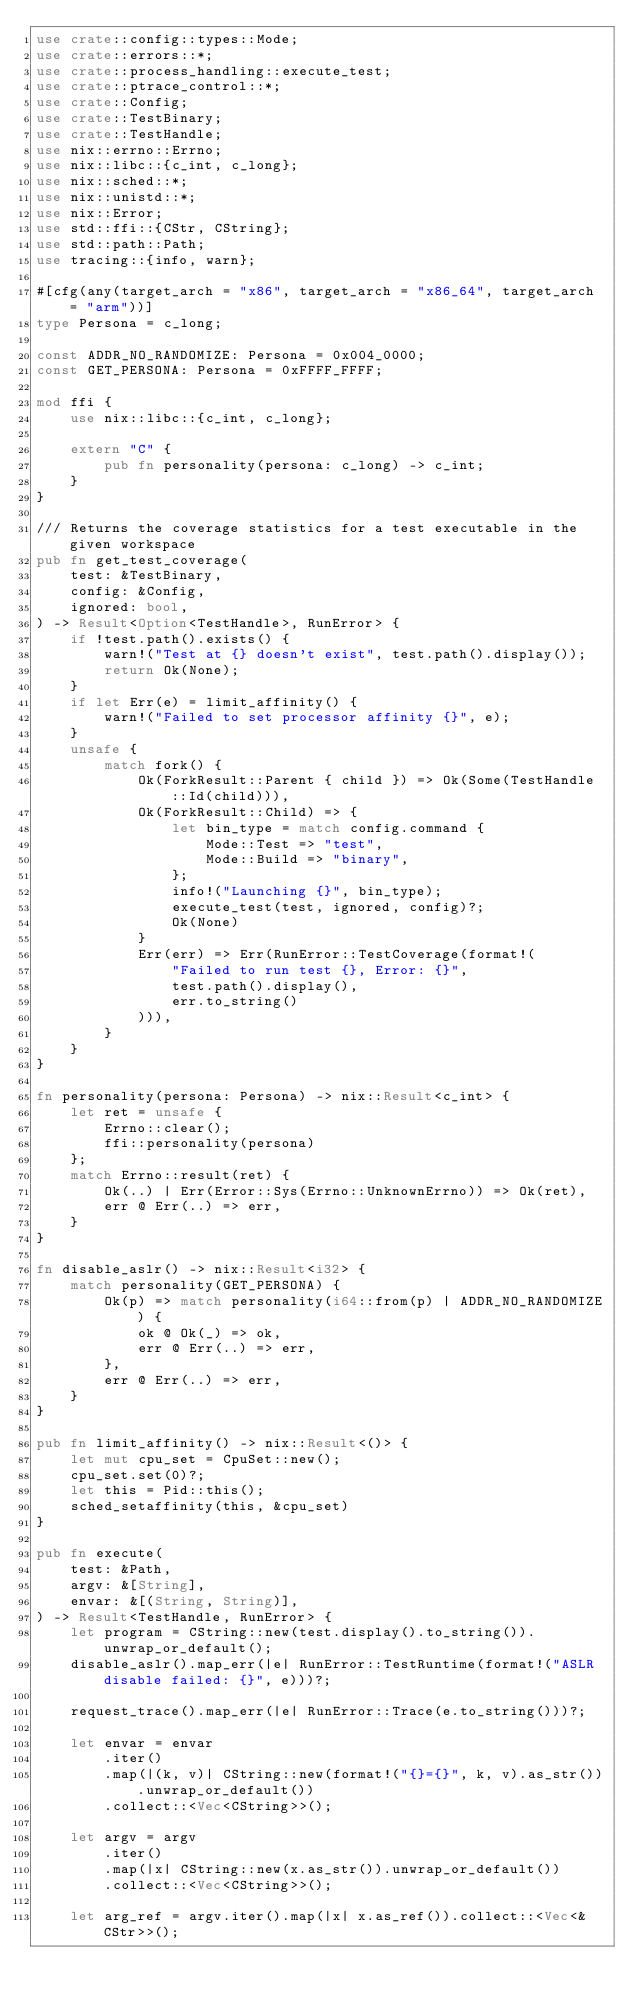Convert code to text. <code><loc_0><loc_0><loc_500><loc_500><_Rust_>use crate::config::types::Mode;
use crate::errors::*;
use crate::process_handling::execute_test;
use crate::ptrace_control::*;
use crate::Config;
use crate::TestBinary;
use crate::TestHandle;
use nix::errno::Errno;
use nix::libc::{c_int, c_long};
use nix::sched::*;
use nix::unistd::*;
use nix::Error;
use std::ffi::{CStr, CString};
use std::path::Path;
use tracing::{info, warn};

#[cfg(any(target_arch = "x86", target_arch = "x86_64", target_arch = "arm"))]
type Persona = c_long;

const ADDR_NO_RANDOMIZE: Persona = 0x004_0000;
const GET_PERSONA: Persona = 0xFFFF_FFFF;

mod ffi {
    use nix::libc::{c_int, c_long};

    extern "C" {
        pub fn personality(persona: c_long) -> c_int;
    }
}

/// Returns the coverage statistics for a test executable in the given workspace
pub fn get_test_coverage(
    test: &TestBinary,
    config: &Config,
    ignored: bool,
) -> Result<Option<TestHandle>, RunError> {
    if !test.path().exists() {
        warn!("Test at {} doesn't exist", test.path().display());
        return Ok(None);
    }
    if let Err(e) = limit_affinity() {
        warn!("Failed to set processor affinity {}", e);
    }
    unsafe {
        match fork() {
            Ok(ForkResult::Parent { child }) => Ok(Some(TestHandle::Id(child))),
            Ok(ForkResult::Child) => {
                let bin_type = match config.command {
                    Mode::Test => "test",
                    Mode::Build => "binary",
                };
                info!("Launching {}", bin_type);
                execute_test(test, ignored, config)?;
                Ok(None)
            }
            Err(err) => Err(RunError::TestCoverage(format!(
                "Failed to run test {}, Error: {}",
                test.path().display(),
                err.to_string()
            ))),
        }
    }
}

fn personality(persona: Persona) -> nix::Result<c_int> {
    let ret = unsafe {
        Errno::clear();
        ffi::personality(persona)
    };
    match Errno::result(ret) {
        Ok(..) | Err(Error::Sys(Errno::UnknownErrno)) => Ok(ret),
        err @ Err(..) => err,
    }
}

fn disable_aslr() -> nix::Result<i32> {
    match personality(GET_PERSONA) {
        Ok(p) => match personality(i64::from(p) | ADDR_NO_RANDOMIZE) {
            ok @ Ok(_) => ok,
            err @ Err(..) => err,
        },
        err @ Err(..) => err,
    }
}

pub fn limit_affinity() -> nix::Result<()> {
    let mut cpu_set = CpuSet::new();
    cpu_set.set(0)?;
    let this = Pid::this();
    sched_setaffinity(this, &cpu_set)
}

pub fn execute(
    test: &Path,
    argv: &[String],
    envar: &[(String, String)],
) -> Result<TestHandle, RunError> {
    let program = CString::new(test.display().to_string()).unwrap_or_default();
    disable_aslr().map_err(|e| RunError::TestRuntime(format!("ASLR disable failed: {}", e)))?;

    request_trace().map_err(|e| RunError::Trace(e.to_string()))?;

    let envar = envar
        .iter()
        .map(|(k, v)| CString::new(format!("{}={}", k, v).as_str()).unwrap_or_default())
        .collect::<Vec<CString>>();

    let argv = argv
        .iter()
        .map(|x| CString::new(x.as_str()).unwrap_or_default())
        .collect::<Vec<CString>>();

    let arg_ref = argv.iter().map(|x| x.as_ref()).collect::<Vec<&CStr>>();</code> 